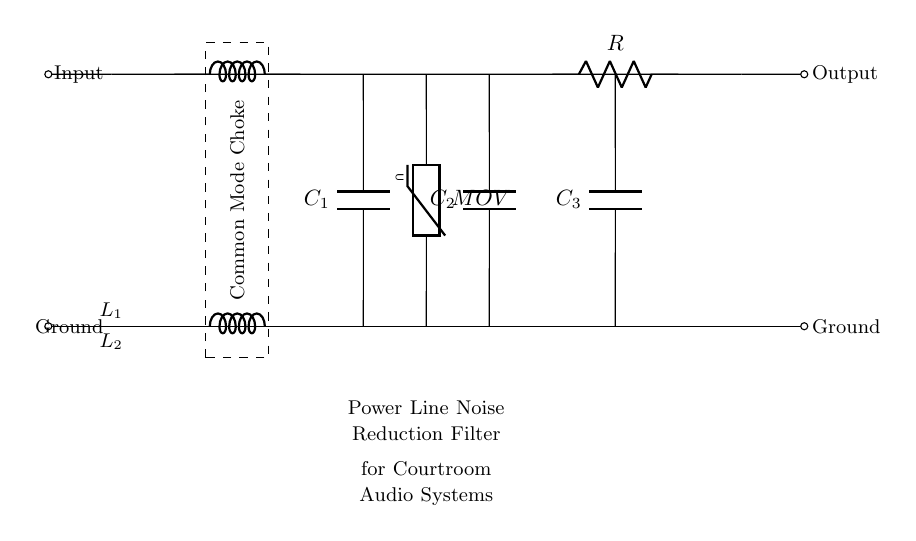What are the main components of the filter? The filter primarily consists of a common mode choke, capacitors, a resistor, and a varistor, which are essential in mitigating power line noise.
Answer: common mode choke, capacitors, resistor, varistor What is the function of the common mode choke in this circuit? The common mode choke serves to block high-frequency differential noise while allowing the desired signal to pass. It does this by providing inductance that reacts to the noise signals.
Answer: noise blocking How many capacitors are present in the circuit? The circuit contains three capacitors, which are typically used for coupling or bypassing in filtering applications.
Answer: three What role does the varistor play in this circuit? The varistor serves as a voltage-dependent resistor that protects the circuit from voltage spikes, absorbing excess energy to prevent damage to sensitive components.
Answer: voltage spike protection If the capacitors have a capacitance of four microfarads each, what is the total capacitance? Since capacitors in parallel sum their capacitance, the total capacitance would be the sum of the capacitances of the three capacitors: four plus four plus four, equaling twelve microfarads.
Answer: twelve microfarads What is the primary application of this filter? The primary application of this filter is to reduce power line noise in courtroom audio systems, ensuring clear audio quality during court proceedings.
Answer: courtroom audio systems 